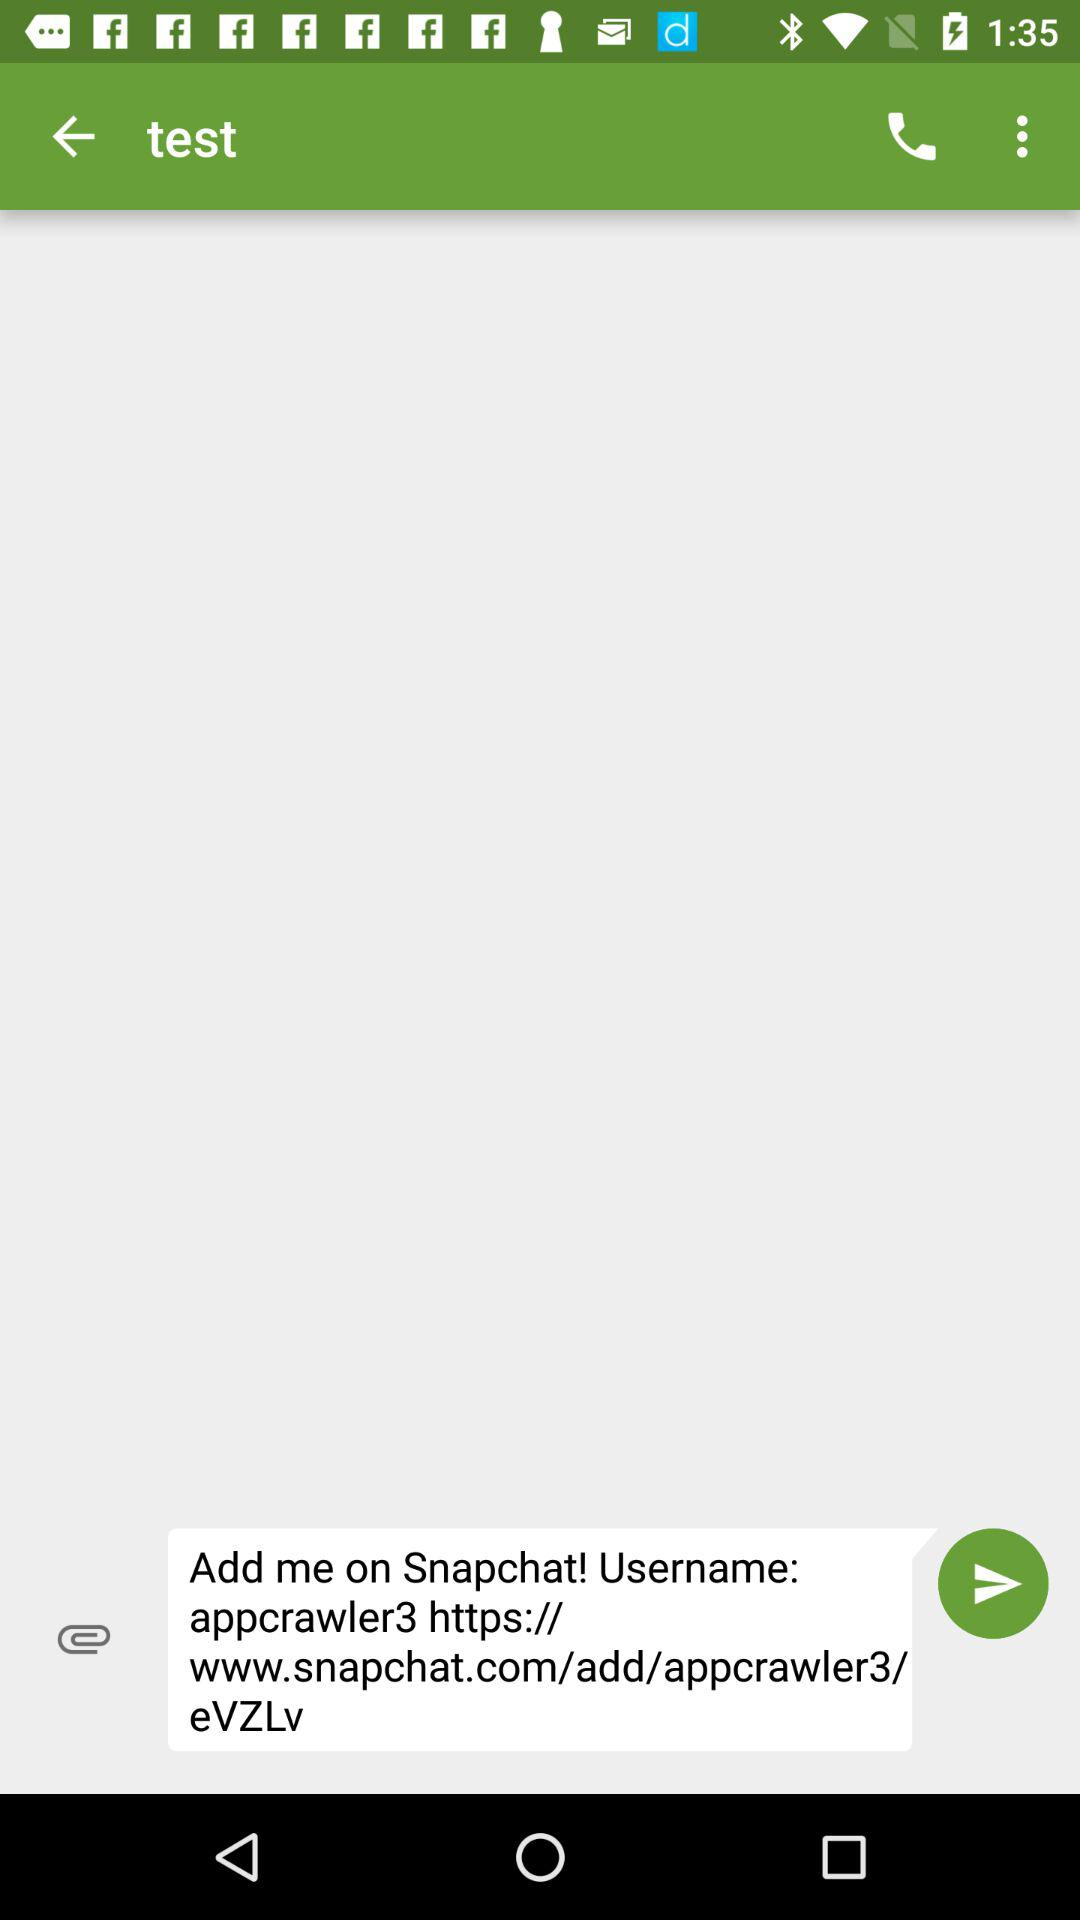What is the user's name?
When the provided information is insufficient, respond with <no answer>. <no answer> 